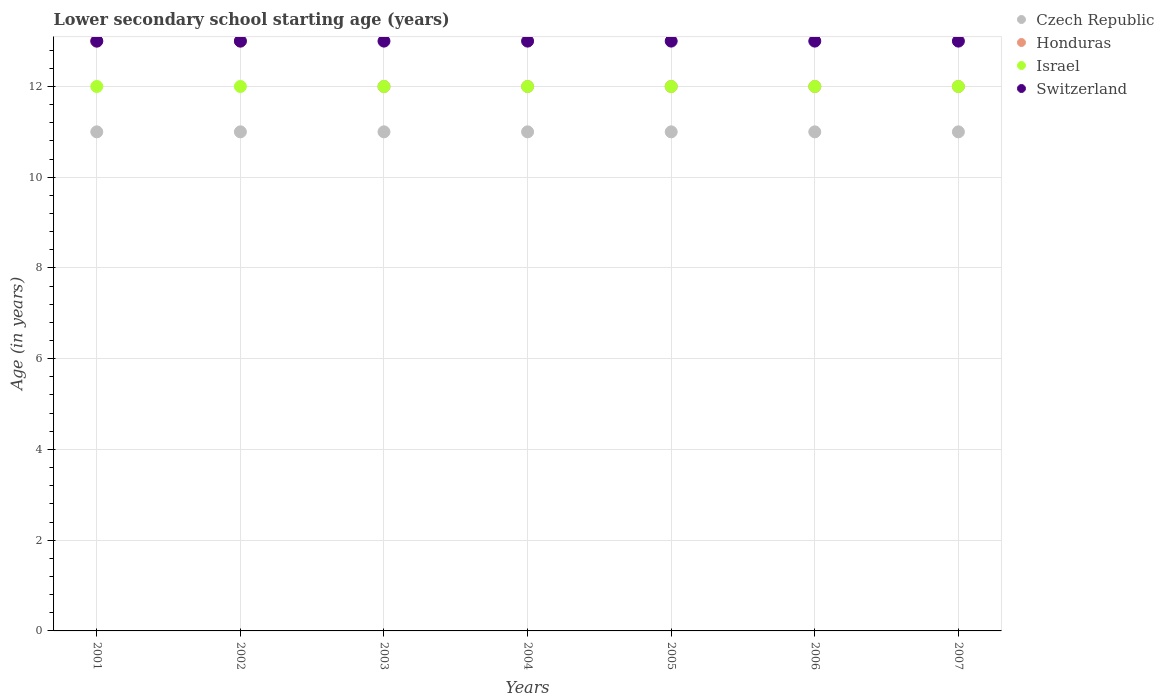What is the lower secondary school starting age of children in Israel in 2006?
Provide a short and direct response. 12. Across all years, what is the maximum lower secondary school starting age of children in Switzerland?
Ensure brevity in your answer.  13. Across all years, what is the minimum lower secondary school starting age of children in Czech Republic?
Keep it short and to the point. 11. What is the total lower secondary school starting age of children in Czech Republic in the graph?
Your answer should be very brief. 77. What is the difference between the lower secondary school starting age of children in Honduras in 2004 and that in 2007?
Give a very brief answer. 0. What is the average lower secondary school starting age of children in Czech Republic per year?
Your response must be concise. 11. In the year 2004, what is the difference between the lower secondary school starting age of children in Israel and lower secondary school starting age of children in Honduras?
Your answer should be compact. 0. What is the ratio of the lower secondary school starting age of children in Czech Republic in 2005 to that in 2006?
Make the answer very short. 1. Is the difference between the lower secondary school starting age of children in Israel in 2002 and 2003 greater than the difference between the lower secondary school starting age of children in Honduras in 2002 and 2003?
Offer a very short reply. No. What is the difference between the highest and the second highest lower secondary school starting age of children in Honduras?
Ensure brevity in your answer.  0. Is the lower secondary school starting age of children in Switzerland strictly greater than the lower secondary school starting age of children in Honduras over the years?
Keep it short and to the point. No. Is the lower secondary school starting age of children in Honduras strictly less than the lower secondary school starting age of children in Israel over the years?
Your response must be concise. No. How many years are there in the graph?
Provide a succinct answer. 7. Are the values on the major ticks of Y-axis written in scientific E-notation?
Keep it short and to the point. No. What is the title of the graph?
Your answer should be compact. Lower secondary school starting age (years). What is the label or title of the X-axis?
Provide a short and direct response. Years. What is the label or title of the Y-axis?
Offer a terse response. Age (in years). What is the Age (in years) in Honduras in 2001?
Offer a terse response. 13. What is the Age (in years) of Czech Republic in 2002?
Ensure brevity in your answer.  11. What is the Age (in years) of Israel in 2002?
Keep it short and to the point. 12. What is the Age (in years) in Switzerland in 2002?
Your answer should be very brief. 13. What is the Age (in years) of Czech Republic in 2003?
Make the answer very short. 11. What is the Age (in years) of Israel in 2003?
Give a very brief answer. 12. What is the Age (in years) of Switzerland in 2003?
Your response must be concise. 13. What is the Age (in years) of Czech Republic in 2004?
Your answer should be very brief. 11. What is the Age (in years) of Honduras in 2004?
Provide a succinct answer. 12. What is the Age (in years) in Israel in 2004?
Your response must be concise. 12. What is the Age (in years) of Switzerland in 2004?
Your answer should be very brief. 13. What is the Age (in years) in Honduras in 2005?
Ensure brevity in your answer.  12. What is the Age (in years) in Israel in 2005?
Provide a succinct answer. 12. What is the Age (in years) in Switzerland in 2005?
Give a very brief answer. 13. What is the Age (in years) of Honduras in 2006?
Keep it short and to the point. 12. What is the Age (in years) in Switzerland in 2006?
Provide a succinct answer. 13. What is the Age (in years) in Honduras in 2007?
Your response must be concise. 12. Across all years, what is the maximum Age (in years) of Czech Republic?
Keep it short and to the point. 11. Across all years, what is the maximum Age (in years) in Israel?
Ensure brevity in your answer.  12. Across all years, what is the maximum Age (in years) in Switzerland?
Ensure brevity in your answer.  13. Across all years, what is the minimum Age (in years) in Honduras?
Your response must be concise. 12. Across all years, what is the minimum Age (in years) in Switzerland?
Offer a terse response. 13. What is the total Age (in years) of Czech Republic in the graph?
Your answer should be very brief. 77. What is the total Age (in years) of Honduras in the graph?
Your response must be concise. 86. What is the total Age (in years) in Israel in the graph?
Offer a terse response. 84. What is the total Age (in years) of Switzerland in the graph?
Give a very brief answer. 91. What is the difference between the Age (in years) of Czech Republic in 2001 and that in 2002?
Offer a very short reply. 0. What is the difference between the Age (in years) of Honduras in 2001 and that in 2002?
Provide a succinct answer. 0. What is the difference between the Age (in years) of Honduras in 2001 and that in 2003?
Your answer should be compact. 1. What is the difference between the Age (in years) of Israel in 2001 and that in 2003?
Ensure brevity in your answer.  0. What is the difference between the Age (in years) of Honduras in 2001 and that in 2005?
Your answer should be very brief. 1. What is the difference between the Age (in years) of Israel in 2001 and that in 2005?
Offer a very short reply. 0. What is the difference between the Age (in years) of Switzerland in 2001 and that in 2005?
Your answer should be very brief. 0. What is the difference between the Age (in years) in Czech Republic in 2001 and that in 2006?
Offer a very short reply. 0. What is the difference between the Age (in years) of Israel in 2001 and that in 2006?
Keep it short and to the point. 0. What is the difference between the Age (in years) in Switzerland in 2001 and that in 2006?
Make the answer very short. 0. What is the difference between the Age (in years) of Czech Republic in 2001 and that in 2007?
Make the answer very short. 0. What is the difference between the Age (in years) of Honduras in 2001 and that in 2007?
Provide a short and direct response. 1. What is the difference between the Age (in years) of Israel in 2001 and that in 2007?
Offer a terse response. 0. What is the difference between the Age (in years) in Switzerland in 2001 and that in 2007?
Offer a terse response. 0. What is the difference between the Age (in years) in Honduras in 2002 and that in 2003?
Provide a succinct answer. 1. What is the difference between the Age (in years) of Israel in 2002 and that in 2003?
Provide a short and direct response. 0. What is the difference between the Age (in years) of Czech Republic in 2002 and that in 2004?
Keep it short and to the point. 0. What is the difference between the Age (in years) in Honduras in 2002 and that in 2004?
Your answer should be very brief. 1. What is the difference between the Age (in years) of Israel in 2002 and that in 2004?
Offer a terse response. 0. What is the difference between the Age (in years) in Switzerland in 2002 and that in 2004?
Keep it short and to the point. 0. What is the difference between the Age (in years) in Czech Republic in 2002 and that in 2005?
Offer a very short reply. 0. What is the difference between the Age (in years) in Honduras in 2002 and that in 2005?
Offer a terse response. 1. What is the difference between the Age (in years) in Czech Republic in 2002 and that in 2006?
Give a very brief answer. 0. What is the difference between the Age (in years) of Honduras in 2002 and that in 2006?
Keep it short and to the point. 1. What is the difference between the Age (in years) of Switzerland in 2002 and that in 2006?
Your answer should be compact. 0. What is the difference between the Age (in years) in Czech Republic in 2002 and that in 2007?
Provide a succinct answer. 0. What is the difference between the Age (in years) in Israel in 2002 and that in 2007?
Ensure brevity in your answer.  0. What is the difference between the Age (in years) in Czech Republic in 2003 and that in 2004?
Provide a short and direct response. 0. What is the difference between the Age (in years) of Czech Republic in 2003 and that in 2005?
Make the answer very short. 0. What is the difference between the Age (in years) in Switzerland in 2003 and that in 2005?
Make the answer very short. 0. What is the difference between the Age (in years) of Israel in 2003 and that in 2006?
Offer a terse response. 0. What is the difference between the Age (in years) in Switzerland in 2003 and that in 2006?
Your response must be concise. 0. What is the difference between the Age (in years) of Czech Republic in 2003 and that in 2007?
Offer a terse response. 0. What is the difference between the Age (in years) of Switzerland in 2003 and that in 2007?
Offer a very short reply. 0. What is the difference between the Age (in years) in Israel in 2004 and that in 2005?
Your response must be concise. 0. What is the difference between the Age (in years) of Israel in 2004 and that in 2006?
Offer a terse response. 0. What is the difference between the Age (in years) of Switzerland in 2004 and that in 2006?
Make the answer very short. 0. What is the difference between the Age (in years) of Israel in 2004 and that in 2007?
Provide a short and direct response. 0. What is the difference between the Age (in years) of Czech Republic in 2005 and that in 2006?
Ensure brevity in your answer.  0. What is the difference between the Age (in years) of Israel in 2005 and that in 2006?
Make the answer very short. 0. What is the difference between the Age (in years) of Czech Republic in 2005 and that in 2007?
Offer a terse response. 0. What is the difference between the Age (in years) in Honduras in 2005 and that in 2007?
Provide a succinct answer. 0. What is the difference between the Age (in years) of Israel in 2005 and that in 2007?
Make the answer very short. 0. What is the difference between the Age (in years) in Switzerland in 2005 and that in 2007?
Give a very brief answer. 0. What is the difference between the Age (in years) of Czech Republic in 2001 and the Age (in years) of Honduras in 2002?
Offer a terse response. -2. What is the difference between the Age (in years) in Czech Republic in 2001 and the Age (in years) in Switzerland in 2002?
Provide a succinct answer. -2. What is the difference between the Age (in years) of Israel in 2001 and the Age (in years) of Switzerland in 2002?
Give a very brief answer. -1. What is the difference between the Age (in years) of Czech Republic in 2001 and the Age (in years) of Honduras in 2003?
Ensure brevity in your answer.  -1. What is the difference between the Age (in years) of Czech Republic in 2001 and the Age (in years) of Israel in 2003?
Your answer should be very brief. -1. What is the difference between the Age (in years) of Czech Republic in 2001 and the Age (in years) of Switzerland in 2003?
Provide a succinct answer. -2. What is the difference between the Age (in years) in Honduras in 2001 and the Age (in years) in Israel in 2003?
Your answer should be very brief. 1. What is the difference between the Age (in years) of Honduras in 2001 and the Age (in years) of Switzerland in 2003?
Your response must be concise. 0. What is the difference between the Age (in years) in Czech Republic in 2001 and the Age (in years) in Honduras in 2004?
Provide a short and direct response. -1. What is the difference between the Age (in years) in Czech Republic in 2001 and the Age (in years) in Switzerland in 2004?
Your answer should be very brief. -2. What is the difference between the Age (in years) in Czech Republic in 2001 and the Age (in years) in Honduras in 2005?
Make the answer very short. -1. What is the difference between the Age (in years) in Czech Republic in 2001 and the Age (in years) in Israel in 2005?
Offer a terse response. -1. What is the difference between the Age (in years) in Czech Republic in 2001 and the Age (in years) in Honduras in 2006?
Your response must be concise. -1. What is the difference between the Age (in years) in Czech Republic in 2001 and the Age (in years) in Israel in 2006?
Your answer should be compact. -1. What is the difference between the Age (in years) in Czech Republic in 2001 and the Age (in years) in Switzerland in 2006?
Your answer should be very brief. -2. What is the difference between the Age (in years) of Honduras in 2001 and the Age (in years) of Israel in 2006?
Offer a terse response. 1. What is the difference between the Age (in years) of Czech Republic in 2001 and the Age (in years) of Honduras in 2007?
Make the answer very short. -1. What is the difference between the Age (in years) of Czech Republic in 2001 and the Age (in years) of Switzerland in 2007?
Keep it short and to the point. -2. What is the difference between the Age (in years) in Israel in 2001 and the Age (in years) in Switzerland in 2007?
Give a very brief answer. -1. What is the difference between the Age (in years) in Czech Republic in 2002 and the Age (in years) in Israel in 2003?
Give a very brief answer. -1. What is the difference between the Age (in years) of Israel in 2002 and the Age (in years) of Switzerland in 2003?
Make the answer very short. -1. What is the difference between the Age (in years) in Czech Republic in 2002 and the Age (in years) in Honduras in 2004?
Give a very brief answer. -1. What is the difference between the Age (in years) in Czech Republic in 2002 and the Age (in years) in Switzerland in 2004?
Make the answer very short. -2. What is the difference between the Age (in years) in Honduras in 2002 and the Age (in years) in Israel in 2004?
Give a very brief answer. 1. What is the difference between the Age (in years) in Israel in 2002 and the Age (in years) in Switzerland in 2004?
Your answer should be compact. -1. What is the difference between the Age (in years) of Czech Republic in 2002 and the Age (in years) of Switzerland in 2005?
Provide a succinct answer. -2. What is the difference between the Age (in years) in Honduras in 2002 and the Age (in years) in Israel in 2005?
Your answer should be compact. 1. What is the difference between the Age (in years) in Honduras in 2002 and the Age (in years) in Switzerland in 2005?
Give a very brief answer. 0. What is the difference between the Age (in years) in Israel in 2002 and the Age (in years) in Switzerland in 2005?
Give a very brief answer. -1. What is the difference between the Age (in years) in Czech Republic in 2002 and the Age (in years) in Honduras in 2006?
Ensure brevity in your answer.  -1. What is the difference between the Age (in years) in Czech Republic in 2002 and the Age (in years) in Israel in 2006?
Provide a short and direct response. -1. What is the difference between the Age (in years) of Czech Republic in 2002 and the Age (in years) of Switzerland in 2006?
Your answer should be compact. -2. What is the difference between the Age (in years) of Honduras in 2002 and the Age (in years) of Israel in 2006?
Offer a terse response. 1. What is the difference between the Age (in years) in Czech Republic in 2002 and the Age (in years) in Honduras in 2007?
Your response must be concise. -1. What is the difference between the Age (in years) of Honduras in 2002 and the Age (in years) of Israel in 2007?
Ensure brevity in your answer.  1. What is the difference between the Age (in years) of Honduras in 2002 and the Age (in years) of Switzerland in 2007?
Make the answer very short. 0. What is the difference between the Age (in years) in Israel in 2002 and the Age (in years) in Switzerland in 2007?
Keep it short and to the point. -1. What is the difference between the Age (in years) in Czech Republic in 2003 and the Age (in years) in Israel in 2004?
Keep it short and to the point. -1. What is the difference between the Age (in years) in Czech Republic in 2003 and the Age (in years) in Switzerland in 2004?
Keep it short and to the point. -2. What is the difference between the Age (in years) of Honduras in 2003 and the Age (in years) of Israel in 2004?
Provide a short and direct response. 0. What is the difference between the Age (in years) in Czech Republic in 2003 and the Age (in years) in Israel in 2005?
Make the answer very short. -1. What is the difference between the Age (in years) of Czech Republic in 2003 and the Age (in years) of Switzerland in 2005?
Your answer should be compact. -2. What is the difference between the Age (in years) of Honduras in 2003 and the Age (in years) of Switzerland in 2005?
Give a very brief answer. -1. What is the difference between the Age (in years) of Czech Republic in 2003 and the Age (in years) of Honduras in 2006?
Keep it short and to the point. -1. What is the difference between the Age (in years) of Czech Republic in 2003 and the Age (in years) of Switzerland in 2006?
Provide a succinct answer. -2. What is the difference between the Age (in years) in Honduras in 2003 and the Age (in years) in Israel in 2006?
Your answer should be very brief. 0. What is the difference between the Age (in years) in Honduras in 2003 and the Age (in years) in Switzerland in 2006?
Give a very brief answer. -1. What is the difference between the Age (in years) in Czech Republic in 2003 and the Age (in years) in Honduras in 2007?
Make the answer very short. -1. What is the difference between the Age (in years) in Czech Republic in 2003 and the Age (in years) in Israel in 2007?
Your answer should be very brief. -1. What is the difference between the Age (in years) in Czech Republic in 2003 and the Age (in years) in Switzerland in 2007?
Ensure brevity in your answer.  -2. What is the difference between the Age (in years) of Honduras in 2003 and the Age (in years) of Israel in 2007?
Provide a short and direct response. 0. What is the difference between the Age (in years) in Israel in 2003 and the Age (in years) in Switzerland in 2007?
Your response must be concise. -1. What is the difference between the Age (in years) in Czech Republic in 2004 and the Age (in years) in Israel in 2005?
Make the answer very short. -1. What is the difference between the Age (in years) in Czech Republic in 2004 and the Age (in years) in Switzerland in 2005?
Offer a very short reply. -2. What is the difference between the Age (in years) of Israel in 2004 and the Age (in years) of Switzerland in 2006?
Offer a very short reply. -1. What is the difference between the Age (in years) in Czech Republic in 2004 and the Age (in years) in Israel in 2007?
Your answer should be very brief. -1. What is the difference between the Age (in years) in Czech Republic in 2004 and the Age (in years) in Switzerland in 2007?
Provide a short and direct response. -2. What is the difference between the Age (in years) of Israel in 2004 and the Age (in years) of Switzerland in 2007?
Your answer should be compact. -1. What is the difference between the Age (in years) of Czech Republic in 2005 and the Age (in years) of Switzerland in 2006?
Offer a terse response. -2. What is the difference between the Age (in years) in Honduras in 2005 and the Age (in years) in Israel in 2006?
Offer a terse response. 0. What is the difference between the Age (in years) in Honduras in 2005 and the Age (in years) in Switzerland in 2006?
Your answer should be very brief. -1. What is the difference between the Age (in years) of Israel in 2005 and the Age (in years) of Switzerland in 2006?
Give a very brief answer. -1. What is the difference between the Age (in years) in Czech Republic in 2005 and the Age (in years) in Honduras in 2007?
Your answer should be very brief. -1. What is the difference between the Age (in years) in Czech Republic in 2005 and the Age (in years) in Israel in 2007?
Offer a terse response. -1. What is the difference between the Age (in years) in Czech Republic in 2005 and the Age (in years) in Switzerland in 2007?
Your answer should be very brief. -2. What is the difference between the Age (in years) of Czech Republic in 2006 and the Age (in years) of Honduras in 2007?
Make the answer very short. -1. What is the difference between the Age (in years) in Czech Republic in 2006 and the Age (in years) in Israel in 2007?
Keep it short and to the point. -1. What is the difference between the Age (in years) in Honduras in 2006 and the Age (in years) in Switzerland in 2007?
Your response must be concise. -1. What is the difference between the Age (in years) of Israel in 2006 and the Age (in years) of Switzerland in 2007?
Provide a succinct answer. -1. What is the average Age (in years) in Czech Republic per year?
Your answer should be very brief. 11. What is the average Age (in years) in Honduras per year?
Provide a succinct answer. 12.29. What is the average Age (in years) in Switzerland per year?
Your response must be concise. 13. In the year 2001, what is the difference between the Age (in years) in Czech Republic and Age (in years) in Honduras?
Your answer should be very brief. -2. In the year 2001, what is the difference between the Age (in years) in Czech Republic and Age (in years) in Israel?
Your response must be concise. -1. In the year 2001, what is the difference between the Age (in years) in Czech Republic and Age (in years) in Switzerland?
Your answer should be compact. -2. In the year 2001, what is the difference between the Age (in years) in Honduras and Age (in years) in Israel?
Your response must be concise. 1. In the year 2002, what is the difference between the Age (in years) in Czech Republic and Age (in years) in Israel?
Offer a terse response. -1. In the year 2002, what is the difference between the Age (in years) of Czech Republic and Age (in years) of Switzerland?
Ensure brevity in your answer.  -2. In the year 2002, what is the difference between the Age (in years) in Honduras and Age (in years) in Switzerland?
Offer a very short reply. 0. In the year 2002, what is the difference between the Age (in years) of Israel and Age (in years) of Switzerland?
Keep it short and to the point. -1. In the year 2003, what is the difference between the Age (in years) of Czech Republic and Age (in years) of Honduras?
Provide a succinct answer. -1. In the year 2003, what is the difference between the Age (in years) of Czech Republic and Age (in years) of Switzerland?
Your answer should be compact. -2. In the year 2003, what is the difference between the Age (in years) of Honduras and Age (in years) of Switzerland?
Provide a short and direct response. -1. In the year 2004, what is the difference between the Age (in years) of Czech Republic and Age (in years) of Honduras?
Offer a terse response. -1. In the year 2004, what is the difference between the Age (in years) in Czech Republic and Age (in years) in Israel?
Offer a very short reply. -1. In the year 2004, what is the difference between the Age (in years) of Honduras and Age (in years) of Israel?
Make the answer very short. 0. In the year 2004, what is the difference between the Age (in years) in Honduras and Age (in years) in Switzerland?
Offer a terse response. -1. In the year 2005, what is the difference between the Age (in years) in Czech Republic and Age (in years) in Honduras?
Offer a very short reply. -1. In the year 2005, what is the difference between the Age (in years) in Israel and Age (in years) in Switzerland?
Offer a very short reply. -1. In the year 2006, what is the difference between the Age (in years) in Czech Republic and Age (in years) in Israel?
Make the answer very short. -1. In the year 2006, what is the difference between the Age (in years) of Czech Republic and Age (in years) of Switzerland?
Your response must be concise. -2. In the year 2006, what is the difference between the Age (in years) of Israel and Age (in years) of Switzerland?
Make the answer very short. -1. In the year 2007, what is the difference between the Age (in years) in Czech Republic and Age (in years) in Honduras?
Offer a terse response. -1. In the year 2007, what is the difference between the Age (in years) in Czech Republic and Age (in years) in Switzerland?
Provide a short and direct response. -2. In the year 2007, what is the difference between the Age (in years) in Honduras and Age (in years) in Israel?
Provide a succinct answer. 0. In the year 2007, what is the difference between the Age (in years) in Honduras and Age (in years) in Switzerland?
Provide a short and direct response. -1. In the year 2007, what is the difference between the Age (in years) in Israel and Age (in years) in Switzerland?
Give a very brief answer. -1. What is the ratio of the Age (in years) in Czech Republic in 2001 to that in 2002?
Offer a terse response. 1. What is the ratio of the Age (in years) of Israel in 2001 to that in 2002?
Provide a succinct answer. 1. What is the ratio of the Age (in years) of Israel in 2001 to that in 2003?
Provide a succinct answer. 1. What is the ratio of the Age (in years) of Switzerland in 2001 to that in 2003?
Your response must be concise. 1. What is the ratio of the Age (in years) in Czech Republic in 2001 to that in 2004?
Make the answer very short. 1. What is the ratio of the Age (in years) in Czech Republic in 2001 to that in 2005?
Provide a short and direct response. 1. What is the ratio of the Age (in years) in Honduras in 2001 to that in 2005?
Make the answer very short. 1.08. What is the ratio of the Age (in years) of Switzerland in 2001 to that in 2005?
Your answer should be very brief. 1. What is the ratio of the Age (in years) in Honduras in 2001 to that in 2006?
Offer a very short reply. 1.08. What is the ratio of the Age (in years) of Switzerland in 2001 to that in 2006?
Make the answer very short. 1. What is the ratio of the Age (in years) in Switzerland in 2001 to that in 2007?
Provide a succinct answer. 1. What is the ratio of the Age (in years) in Czech Republic in 2002 to that in 2004?
Your answer should be compact. 1. What is the ratio of the Age (in years) in Honduras in 2002 to that in 2004?
Give a very brief answer. 1.08. What is the ratio of the Age (in years) of Israel in 2002 to that in 2004?
Your response must be concise. 1. What is the ratio of the Age (in years) of Czech Republic in 2002 to that in 2005?
Offer a very short reply. 1. What is the ratio of the Age (in years) of Israel in 2002 to that in 2005?
Provide a short and direct response. 1. What is the ratio of the Age (in years) in Switzerland in 2002 to that in 2005?
Offer a terse response. 1. What is the ratio of the Age (in years) in Czech Republic in 2002 to that in 2007?
Offer a very short reply. 1. What is the ratio of the Age (in years) in Switzerland in 2002 to that in 2007?
Offer a very short reply. 1. What is the ratio of the Age (in years) in Czech Republic in 2003 to that in 2004?
Offer a terse response. 1. What is the ratio of the Age (in years) in Israel in 2003 to that in 2004?
Provide a short and direct response. 1. What is the ratio of the Age (in years) of Israel in 2003 to that in 2005?
Provide a short and direct response. 1. What is the ratio of the Age (in years) of Switzerland in 2003 to that in 2005?
Give a very brief answer. 1. What is the ratio of the Age (in years) of Czech Republic in 2003 to that in 2006?
Provide a succinct answer. 1. What is the ratio of the Age (in years) of Switzerland in 2003 to that in 2006?
Ensure brevity in your answer.  1. What is the ratio of the Age (in years) in Israel in 2003 to that in 2007?
Provide a short and direct response. 1. What is the ratio of the Age (in years) of Czech Republic in 2004 to that in 2006?
Offer a very short reply. 1. What is the ratio of the Age (in years) of Switzerland in 2004 to that in 2006?
Offer a terse response. 1. What is the ratio of the Age (in years) in Czech Republic in 2004 to that in 2007?
Offer a very short reply. 1. What is the ratio of the Age (in years) in Switzerland in 2004 to that in 2007?
Provide a short and direct response. 1. What is the ratio of the Age (in years) in Israel in 2005 to that in 2006?
Give a very brief answer. 1. What is the ratio of the Age (in years) in Switzerland in 2005 to that in 2006?
Offer a terse response. 1. What is the ratio of the Age (in years) in Switzerland in 2005 to that in 2007?
Make the answer very short. 1. What is the ratio of the Age (in years) of Czech Republic in 2006 to that in 2007?
Your answer should be compact. 1. What is the ratio of the Age (in years) of Israel in 2006 to that in 2007?
Provide a succinct answer. 1. What is the difference between the highest and the second highest Age (in years) of Czech Republic?
Your answer should be compact. 0. What is the difference between the highest and the second highest Age (in years) of Israel?
Offer a terse response. 0. What is the difference between the highest and the second highest Age (in years) of Switzerland?
Provide a succinct answer. 0. What is the difference between the highest and the lowest Age (in years) in Honduras?
Give a very brief answer. 1. 